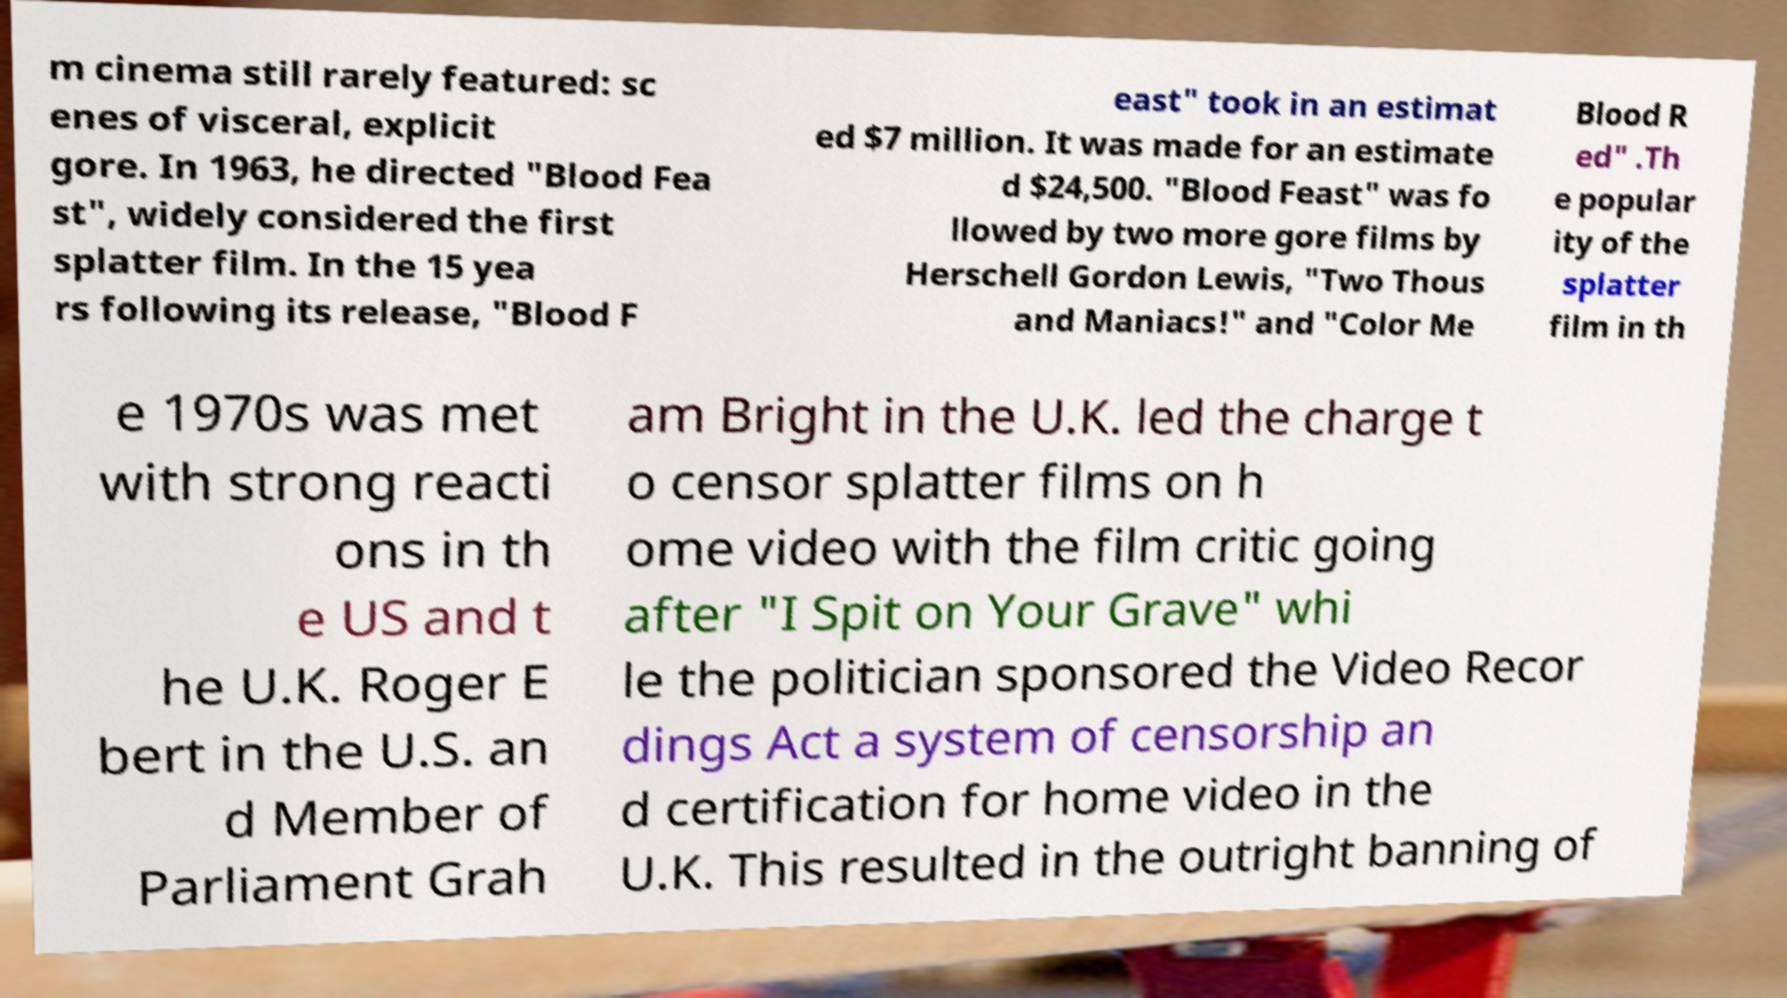Please identify and transcribe the text found in this image. m cinema still rarely featured: sc enes of visceral, explicit gore. In 1963, he directed "Blood Fea st", widely considered the first splatter film. In the 15 yea rs following its release, "Blood F east" took in an estimat ed $7 million. It was made for an estimate d $24,500. "Blood Feast" was fo llowed by two more gore films by Herschell Gordon Lewis, "Two Thous and Maniacs!" and "Color Me Blood R ed" .Th e popular ity of the splatter film in th e 1970s was met with strong reacti ons in th e US and t he U.K. Roger E bert in the U.S. an d Member of Parliament Grah am Bright in the U.K. led the charge t o censor splatter films on h ome video with the film critic going after "I Spit on Your Grave" whi le the politician sponsored the Video Recor dings Act a system of censorship an d certification for home video in the U.K. This resulted in the outright banning of 